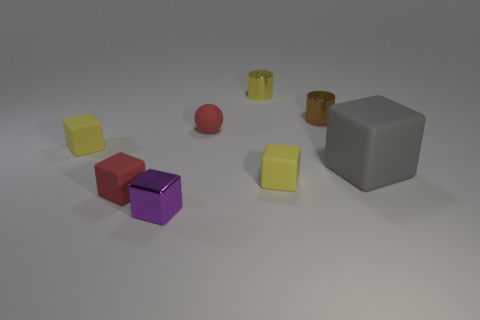What can you infer about the lighting direction in the scene? The lighting in the image suggests that the light source is coming from the upper left corner of the frame. This is reflected in the shadows cast by the objects, which extend towards the bottom right. The shadows are soft and diffuse, indicating that the light source is not overly harsh, creating a calm atmosphere in the scene. 